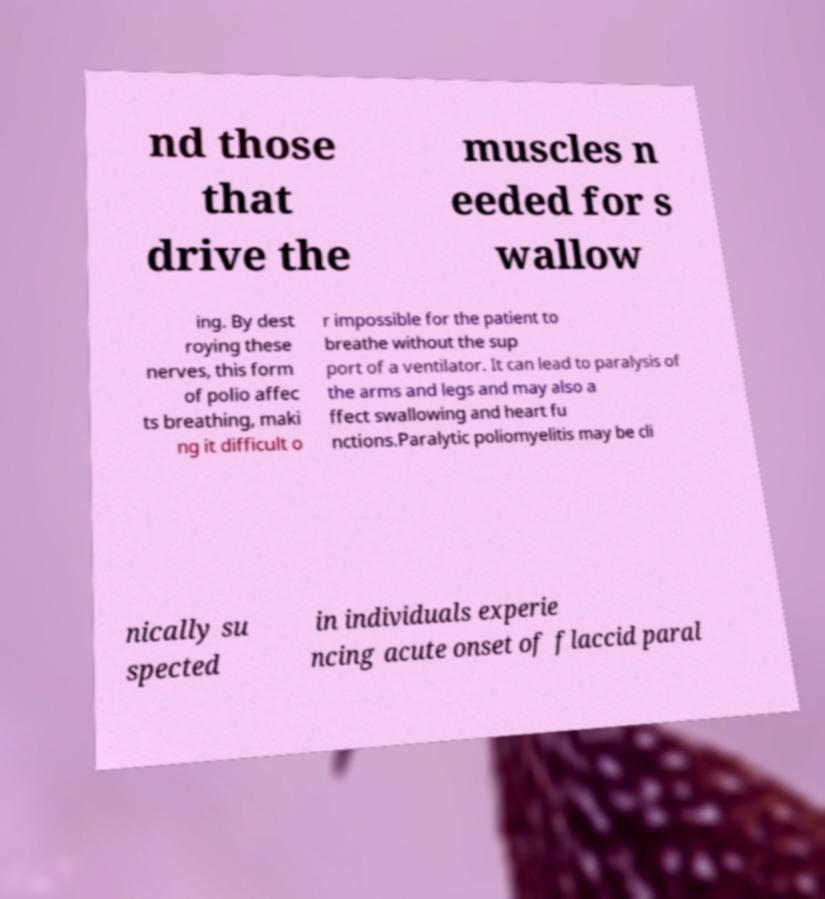Could you extract and type out the text from this image? nd those that drive the muscles n eeded for s wallow ing. By dest roying these nerves, this form of polio affec ts breathing, maki ng it difficult o r impossible for the patient to breathe without the sup port of a ventilator. It can lead to paralysis of the arms and legs and may also a ffect swallowing and heart fu nctions.Paralytic poliomyelitis may be cli nically su spected in individuals experie ncing acute onset of flaccid paral 